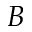<formula> <loc_0><loc_0><loc_500><loc_500>B</formula> 